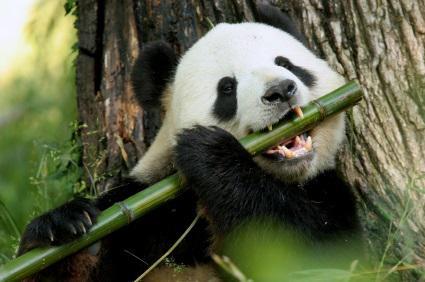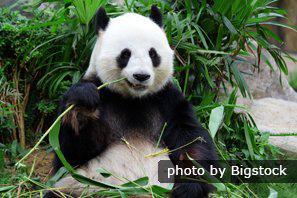The first image is the image on the left, the second image is the image on the right. Examine the images to the left and right. Is the description "There is a lone panda bear sitting down while eating some bamboo." accurate? Answer yes or no. Yes. The first image is the image on the left, the second image is the image on the right. Analyze the images presented: Is the assertion "In both image the panda is eating." valid? Answer yes or no. Yes. The first image is the image on the left, the second image is the image on the right. Given the left and right images, does the statement "There is a Panda sitting and eating bamboo." hold true? Answer yes or no. Yes. 